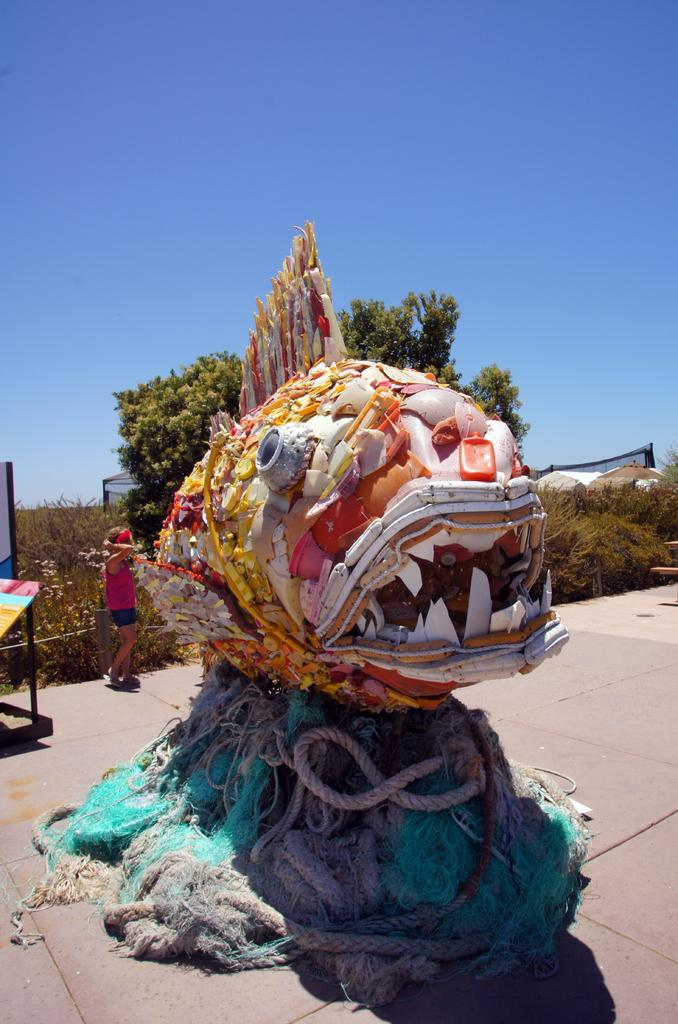What can be seen in the image? There is an object in the image. What is the person in the image doing? A person is standing behind the object. Where is the person standing? The person is standing on the floor. What can be seen in the background of the image? There are plants, trees, and the sky visible in the background of the image. What type of comb is being used to measure the distance between the object and the person in the image? There is no comb present in the image, nor is any measurement being taken. 